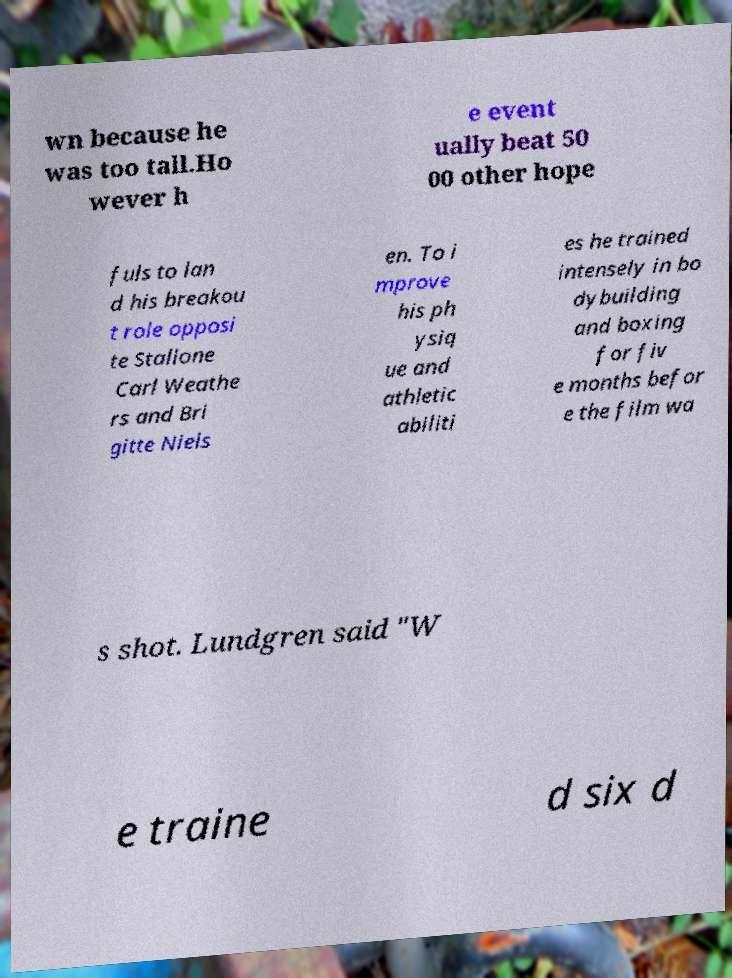I need the written content from this picture converted into text. Can you do that? wn because he was too tall.Ho wever h e event ually beat 50 00 other hope fuls to lan d his breakou t role opposi te Stallone Carl Weathe rs and Bri gitte Niels en. To i mprove his ph ysiq ue and athletic abiliti es he trained intensely in bo dybuilding and boxing for fiv e months befor e the film wa s shot. Lundgren said "W e traine d six d 